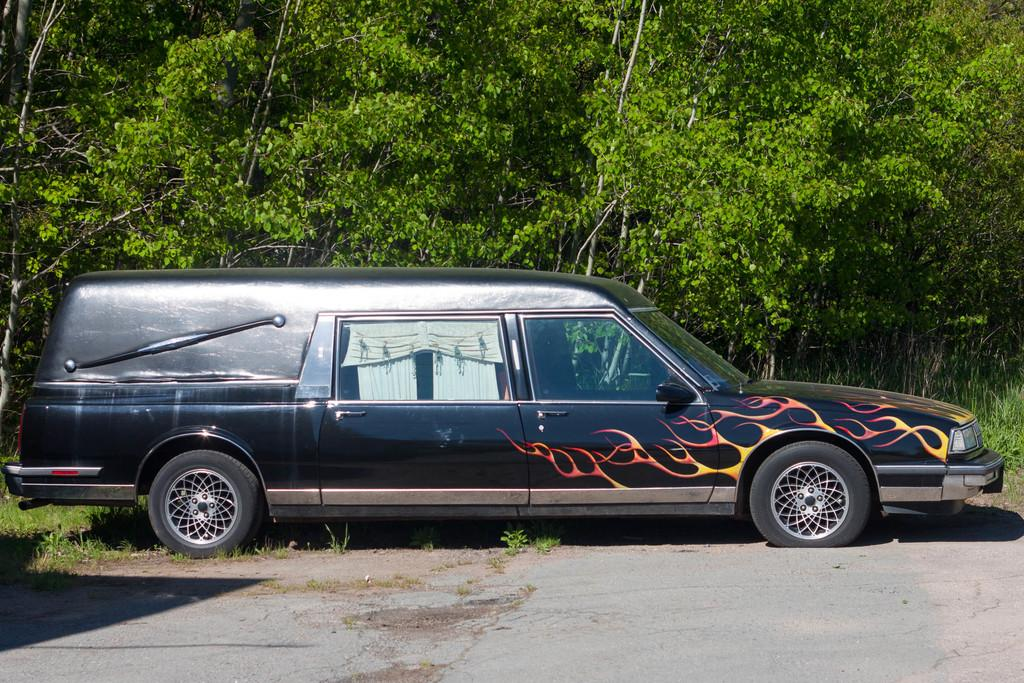What is the main subject of the image? The main subject of the image is a vehicle. What is the color of the vehicle? The vehicle is in black color. What can be seen in the background of the image? There are trees in the background of the image. What is the color of the trees? The trees are in green color. What type of bubble can be seen floating around the vehicle in the image? There is no bubble present in the image; it only features a black vehicle and green trees in the background. 